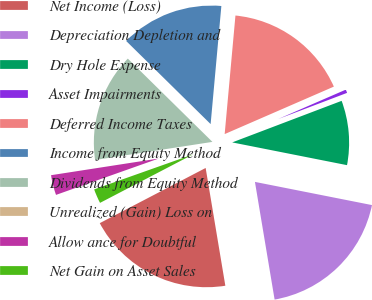Convert chart. <chart><loc_0><loc_0><loc_500><loc_500><pie_chart><fcel>Net Income (Loss)<fcel>Depreciation Depletion and<fcel>Dry Hole Expense<fcel>Asset Impairments<fcel>Deferred Income Taxes<fcel>Income from Equity Method<fcel>Dividends from Equity Method<fcel>Unrealized (Gain) Loss on<fcel>Allow ance for Doubtful<fcel>Net Gain on Asset Sales<nl><fcel>19.99%<fcel>19.25%<fcel>8.89%<fcel>0.75%<fcel>17.03%<fcel>14.07%<fcel>14.81%<fcel>0.01%<fcel>2.97%<fcel>2.23%<nl></chart> 